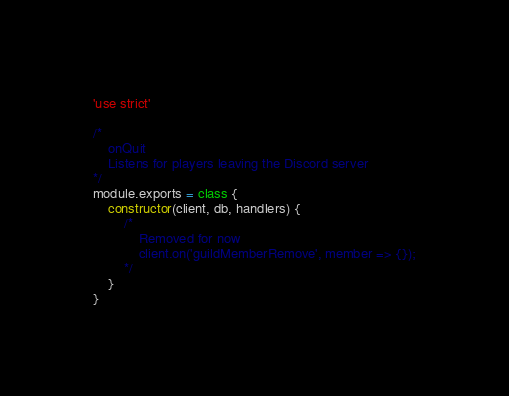<code> <loc_0><loc_0><loc_500><loc_500><_JavaScript_>'use strict'

/*
    onQuit
    Listens for players leaving the Discord server
*/
module.exports = class {
    constructor(client, db, handlers) {
        /*
            Removed for now
            client.on('guildMemberRemove', member => {});
        */
    }
}</code> 